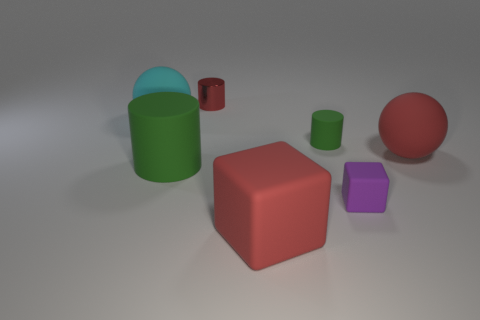Subtract all red cylinders. How many cylinders are left? 2 Add 1 matte blocks. How many objects exist? 8 Subtract all yellow blocks. How many green cylinders are left? 2 Subtract all green cylinders. How many cylinders are left? 1 Subtract all cubes. How many objects are left? 5 Subtract 3 cylinders. How many cylinders are left? 0 Subtract all green cylinders. Subtract all gray balls. How many cylinders are left? 1 Subtract all tiny purple matte things. Subtract all small green things. How many objects are left? 5 Add 5 large matte cubes. How many large matte cubes are left? 6 Add 3 tiny cubes. How many tiny cubes exist? 4 